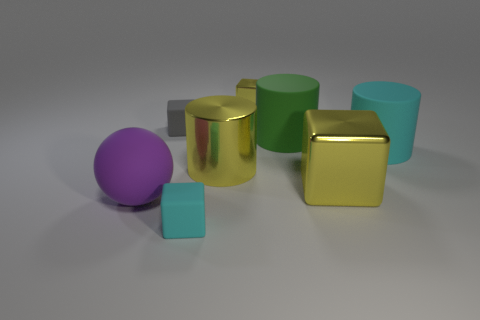What number of other objects are there of the same material as the green cylinder? Including the green cylinder, there are a total of five objects that appear to have a matte finish, possibly indicating they are made of the same or similar material. These include two cubes, another cylinder, and a sphere. 